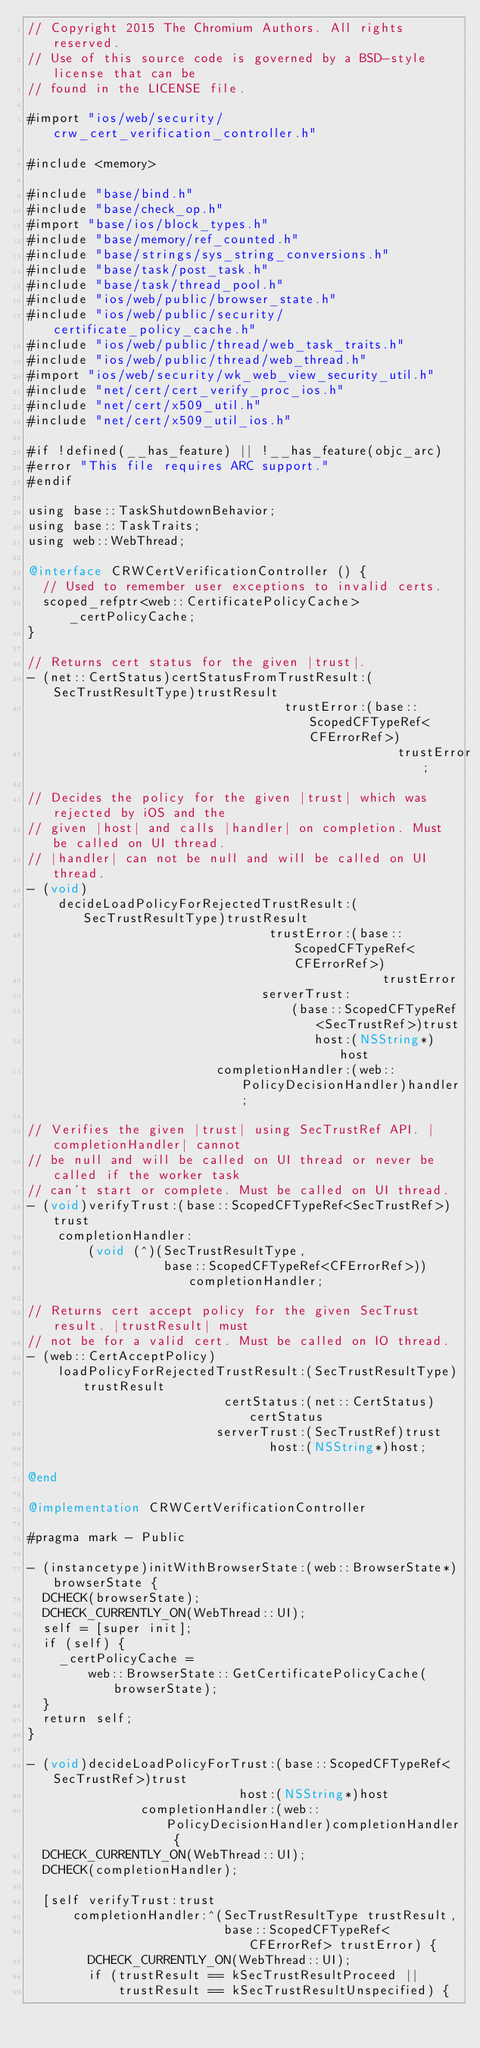<code> <loc_0><loc_0><loc_500><loc_500><_ObjectiveC_>// Copyright 2015 The Chromium Authors. All rights reserved.
// Use of this source code is governed by a BSD-style license that can be
// found in the LICENSE file.

#import "ios/web/security/crw_cert_verification_controller.h"

#include <memory>

#include "base/bind.h"
#include "base/check_op.h"
#import "base/ios/block_types.h"
#include "base/memory/ref_counted.h"
#include "base/strings/sys_string_conversions.h"
#include "base/task/post_task.h"
#include "base/task/thread_pool.h"
#include "ios/web/public/browser_state.h"
#include "ios/web/public/security/certificate_policy_cache.h"
#include "ios/web/public/thread/web_task_traits.h"
#include "ios/web/public/thread/web_thread.h"
#import "ios/web/security/wk_web_view_security_util.h"
#include "net/cert/cert_verify_proc_ios.h"
#include "net/cert/x509_util.h"
#include "net/cert/x509_util_ios.h"

#if !defined(__has_feature) || !__has_feature(objc_arc)
#error "This file requires ARC support."
#endif

using base::TaskShutdownBehavior;
using base::TaskTraits;
using web::WebThread;

@interface CRWCertVerificationController () {
  // Used to remember user exceptions to invalid certs.
  scoped_refptr<web::CertificatePolicyCache> _certPolicyCache;
}

// Returns cert status for the given |trust|.
- (net::CertStatus)certStatusFromTrustResult:(SecTrustResultType)trustResult
                                  trustError:(base::ScopedCFTypeRef<CFErrorRef>)
                                                 trustError;

// Decides the policy for the given |trust| which was rejected by iOS and the
// given |host| and calls |handler| on completion. Must be called on UI thread.
// |handler| can not be null and will be called on UI thread.
- (void)
    decideLoadPolicyForRejectedTrustResult:(SecTrustResultType)trustResult
                                trustError:(base::ScopedCFTypeRef<CFErrorRef>)
                                               trustError
                               serverTrust:
                                   (base::ScopedCFTypeRef<SecTrustRef>)trust
                                      host:(NSString*)host
                         completionHandler:(web::PolicyDecisionHandler)handler;

// Verifies the given |trust| using SecTrustRef API. |completionHandler| cannot
// be null and will be called on UI thread or never be called if the worker task
// can't start or complete. Must be called on UI thread.
- (void)verifyTrust:(base::ScopedCFTypeRef<SecTrustRef>)trust
    completionHandler:
        (void (^)(SecTrustResultType,
                  base::ScopedCFTypeRef<CFErrorRef>))completionHandler;

// Returns cert accept policy for the given SecTrust result. |trustResult| must
// not be for a valid cert. Must be called on IO thread.
- (web::CertAcceptPolicy)
    loadPolicyForRejectedTrustResult:(SecTrustResultType)trustResult
                          certStatus:(net::CertStatus)certStatus
                         serverTrust:(SecTrustRef)trust
                                host:(NSString*)host;

@end

@implementation CRWCertVerificationController

#pragma mark - Public

- (instancetype)initWithBrowserState:(web::BrowserState*)browserState {
  DCHECK(browserState);
  DCHECK_CURRENTLY_ON(WebThread::UI);
  self = [super init];
  if (self) {
    _certPolicyCache =
        web::BrowserState::GetCertificatePolicyCache(browserState);
  }
  return self;
}

- (void)decideLoadPolicyForTrust:(base::ScopedCFTypeRef<SecTrustRef>)trust
                            host:(NSString*)host
               completionHandler:(web::PolicyDecisionHandler)completionHandler {
  DCHECK_CURRENTLY_ON(WebThread::UI);
  DCHECK(completionHandler);

  [self verifyTrust:trust
      completionHandler:^(SecTrustResultType trustResult,
                          base::ScopedCFTypeRef<CFErrorRef> trustError) {
        DCHECK_CURRENTLY_ON(WebThread::UI);
        if (trustResult == kSecTrustResultProceed ||
            trustResult == kSecTrustResultUnspecified) {</code> 